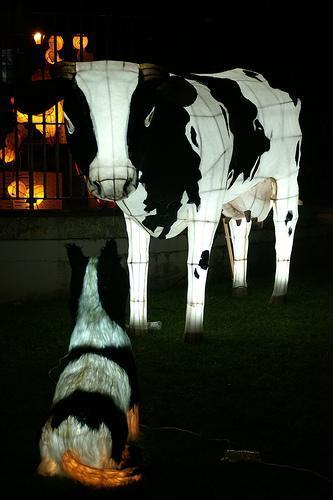How many animals are there?
Give a very brief answer. 2. 